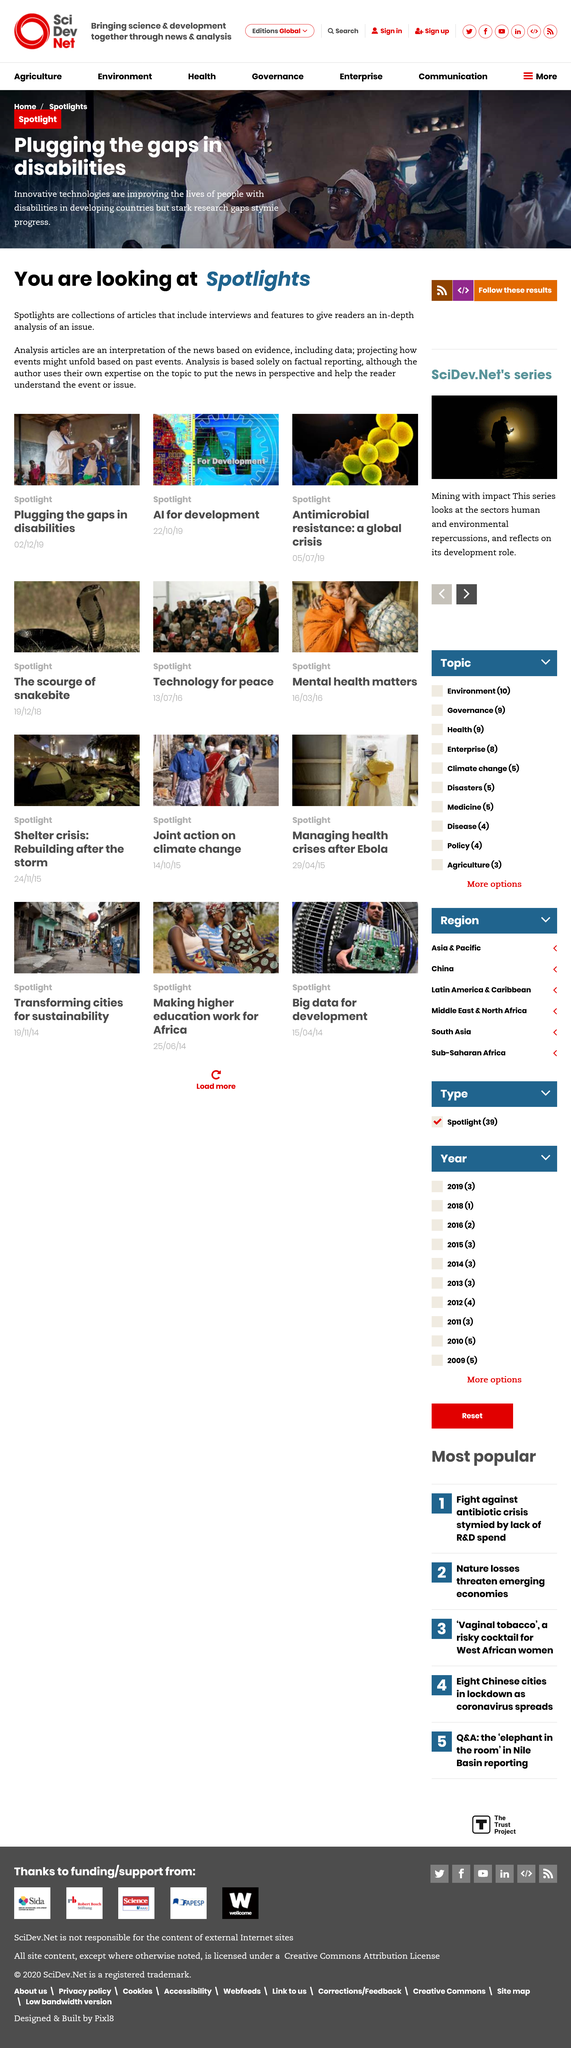List a handful of essential elements in this visual. Yes, spotlights are in-depth and based on evidence. Innovative technologies are significantly improving the lives of individuals with disabilities in developing countries, as stated. The articles feature interviews that provide insights into the experiences of the individuals involved. 